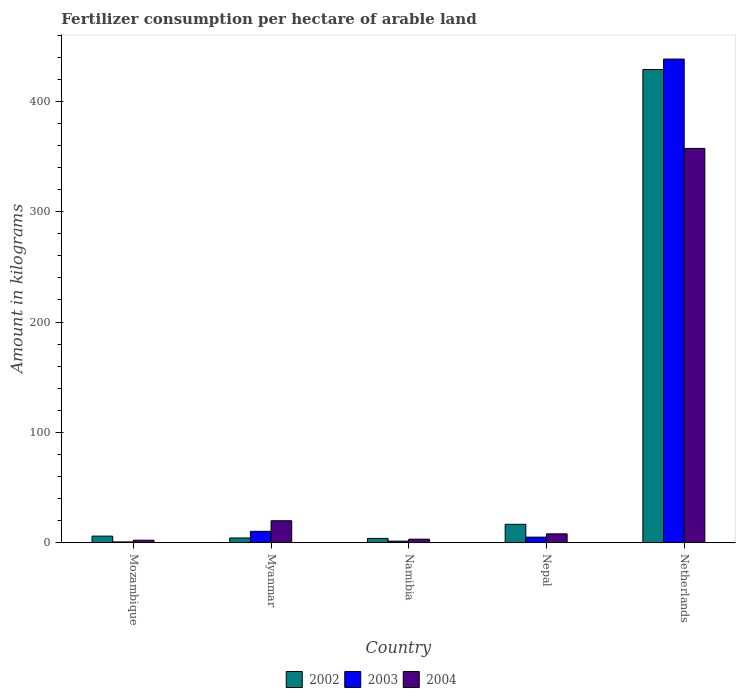How many different coloured bars are there?
Offer a terse response. 3. Are the number of bars per tick equal to the number of legend labels?
Offer a very short reply. Yes. Are the number of bars on each tick of the X-axis equal?
Your answer should be compact. Yes. How many bars are there on the 5th tick from the right?
Your answer should be very brief. 3. What is the label of the 4th group of bars from the left?
Ensure brevity in your answer.  Nepal. In how many cases, is the number of bars for a given country not equal to the number of legend labels?
Your answer should be very brief. 0. What is the amount of fertilizer consumption in 2002 in Namibia?
Keep it short and to the point. 3.9. Across all countries, what is the maximum amount of fertilizer consumption in 2002?
Provide a short and direct response. 428.82. Across all countries, what is the minimum amount of fertilizer consumption in 2003?
Offer a terse response. 0.74. In which country was the amount of fertilizer consumption in 2003 maximum?
Give a very brief answer. Netherlands. In which country was the amount of fertilizer consumption in 2003 minimum?
Provide a succinct answer. Mozambique. What is the total amount of fertilizer consumption in 2004 in the graph?
Your response must be concise. 390.72. What is the difference between the amount of fertilizer consumption in 2003 in Myanmar and that in Netherlands?
Your answer should be compact. -427.98. What is the difference between the amount of fertilizer consumption in 2004 in Mozambique and the amount of fertilizer consumption in 2002 in Namibia?
Offer a terse response. -1.64. What is the average amount of fertilizer consumption in 2004 per country?
Your response must be concise. 78.14. What is the difference between the amount of fertilizer consumption of/in 2003 and amount of fertilizer consumption of/in 2004 in Netherlands?
Offer a very short reply. 80.98. What is the ratio of the amount of fertilizer consumption in 2003 in Mozambique to that in Myanmar?
Give a very brief answer. 0.07. Is the amount of fertilizer consumption in 2004 in Myanmar less than that in Namibia?
Make the answer very short. No. What is the difference between the highest and the second highest amount of fertilizer consumption in 2002?
Offer a very short reply. -412.14. What is the difference between the highest and the lowest amount of fertilizer consumption in 2003?
Provide a short and direct response. 437.56. In how many countries, is the amount of fertilizer consumption in 2003 greater than the average amount of fertilizer consumption in 2003 taken over all countries?
Your response must be concise. 1. Is the sum of the amount of fertilizer consumption in 2004 in Mozambique and Myanmar greater than the maximum amount of fertilizer consumption in 2003 across all countries?
Your answer should be very brief. No. What does the 1st bar from the left in Namibia represents?
Provide a succinct answer. 2002. Is it the case that in every country, the sum of the amount of fertilizer consumption in 2002 and amount of fertilizer consumption in 2003 is greater than the amount of fertilizer consumption in 2004?
Make the answer very short. No. How many bars are there?
Offer a very short reply. 15. Are all the bars in the graph horizontal?
Your answer should be very brief. No. What is the difference between two consecutive major ticks on the Y-axis?
Provide a short and direct response. 100. Does the graph contain grids?
Ensure brevity in your answer.  No. Where does the legend appear in the graph?
Make the answer very short. Bottom center. What is the title of the graph?
Make the answer very short. Fertilizer consumption per hectare of arable land. Does "1986" appear as one of the legend labels in the graph?
Keep it short and to the point. No. What is the label or title of the Y-axis?
Your answer should be very brief. Amount in kilograms. What is the Amount in kilograms of 2002 in Mozambique?
Offer a terse response. 5.98. What is the Amount in kilograms in 2003 in Mozambique?
Provide a succinct answer. 0.74. What is the Amount in kilograms in 2004 in Mozambique?
Make the answer very short. 2.26. What is the Amount in kilograms in 2002 in Myanmar?
Your answer should be compact. 4.29. What is the Amount in kilograms of 2003 in Myanmar?
Ensure brevity in your answer.  10.31. What is the Amount in kilograms in 2004 in Myanmar?
Give a very brief answer. 19.91. What is the Amount in kilograms of 2002 in Namibia?
Your response must be concise. 3.9. What is the Amount in kilograms in 2003 in Namibia?
Your response must be concise. 1.41. What is the Amount in kilograms of 2004 in Namibia?
Give a very brief answer. 3.2. What is the Amount in kilograms of 2002 in Nepal?
Keep it short and to the point. 16.68. What is the Amount in kilograms in 2003 in Nepal?
Your answer should be compact. 5.06. What is the Amount in kilograms of 2004 in Nepal?
Offer a very short reply. 8.03. What is the Amount in kilograms of 2002 in Netherlands?
Make the answer very short. 428.82. What is the Amount in kilograms of 2003 in Netherlands?
Your response must be concise. 438.29. What is the Amount in kilograms in 2004 in Netherlands?
Provide a succinct answer. 357.31. Across all countries, what is the maximum Amount in kilograms of 2002?
Ensure brevity in your answer.  428.82. Across all countries, what is the maximum Amount in kilograms in 2003?
Ensure brevity in your answer.  438.29. Across all countries, what is the maximum Amount in kilograms in 2004?
Provide a succinct answer. 357.31. Across all countries, what is the minimum Amount in kilograms of 2002?
Ensure brevity in your answer.  3.9. Across all countries, what is the minimum Amount in kilograms in 2003?
Offer a very short reply. 0.74. Across all countries, what is the minimum Amount in kilograms in 2004?
Give a very brief answer. 2.26. What is the total Amount in kilograms in 2002 in the graph?
Offer a very short reply. 459.67. What is the total Amount in kilograms in 2003 in the graph?
Keep it short and to the point. 455.81. What is the total Amount in kilograms in 2004 in the graph?
Give a very brief answer. 390.72. What is the difference between the Amount in kilograms in 2002 in Mozambique and that in Myanmar?
Your answer should be very brief. 1.69. What is the difference between the Amount in kilograms of 2003 in Mozambique and that in Myanmar?
Ensure brevity in your answer.  -9.57. What is the difference between the Amount in kilograms in 2004 in Mozambique and that in Myanmar?
Your answer should be compact. -17.65. What is the difference between the Amount in kilograms of 2002 in Mozambique and that in Namibia?
Provide a succinct answer. 2.07. What is the difference between the Amount in kilograms of 2003 in Mozambique and that in Namibia?
Give a very brief answer. -0.67. What is the difference between the Amount in kilograms in 2004 in Mozambique and that in Namibia?
Give a very brief answer. -0.95. What is the difference between the Amount in kilograms in 2002 in Mozambique and that in Nepal?
Your answer should be compact. -10.7. What is the difference between the Amount in kilograms in 2003 in Mozambique and that in Nepal?
Keep it short and to the point. -4.32. What is the difference between the Amount in kilograms in 2004 in Mozambique and that in Nepal?
Your answer should be compact. -5.77. What is the difference between the Amount in kilograms in 2002 in Mozambique and that in Netherlands?
Ensure brevity in your answer.  -422.85. What is the difference between the Amount in kilograms in 2003 in Mozambique and that in Netherlands?
Provide a succinct answer. -437.56. What is the difference between the Amount in kilograms in 2004 in Mozambique and that in Netherlands?
Keep it short and to the point. -355.05. What is the difference between the Amount in kilograms in 2002 in Myanmar and that in Namibia?
Your response must be concise. 0.39. What is the difference between the Amount in kilograms of 2003 in Myanmar and that in Namibia?
Ensure brevity in your answer.  8.9. What is the difference between the Amount in kilograms in 2004 in Myanmar and that in Namibia?
Make the answer very short. 16.71. What is the difference between the Amount in kilograms of 2002 in Myanmar and that in Nepal?
Make the answer very short. -12.39. What is the difference between the Amount in kilograms in 2003 in Myanmar and that in Nepal?
Provide a short and direct response. 5.25. What is the difference between the Amount in kilograms of 2004 in Myanmar and that in Nepal?
Offer a very short reply. 11.89. What is the difference between the Amount in kilograms of 2002 in Myanmar and that in Netherlands?
Keep it short and to the point. -424.53. What is the difference between the Amount in kilograms of 2003 in Myanmar and that in Netherlands?
Provide a short and direct response. -427.98. What is the difference between the Amount in kilograms in 2004 in Myanmar and that in Netherlands?
Keep it short and to the point. -337.4. What is the difference between the Amount in kilograms of 2002 in Namibia and that in Nepal?
Your answer should be very brief. -12.78. What is the difference between the Amount in kilograms of 2003 in Namibia and that in Nepal?
Ensure brevity in your answer.  -3.65. What is the difference between the Amount in kilograms in 2004 in Namibia and that in Nepal?
Offer a terse response. -4.82. What is the difference between the Amount in kilograms in 2002 in Namibia and that in Netherlands?
Give a very brief answer. -424.92. What is the difference between the Amount in kilograms of 2003 in Namibia and that in Netherlands?
Your answer should be compact. -436.88. What is the difference between the Amount in kilograms in 2004 in Namibia and that in Netherlands?
Your answer should be compact. -354.11. What is the difference between the Amount in kilograms in 2002 in Nepal and that in Netherlands?
Your answer should be very brief. -412.14. What is the difference between the Amount in kilograms of 2003 in Nepal and that in Netherlands?
Your answer should be very brief. -433.23. What is the difference between the Amount in kilograms of 2004 in Nepal and that in Netherlands?
Keep it short and to the point. -349.29. What is the difference between the Amount in kilograms in 2002 in Mozambique and the Amount in kilograms in 2003 in Myanmar?
Offer a terse response. -4.33. What is the difference between the Amount in kilograms in 2002 in Mozambique and the Amount in kilograms in 2004 in Myanmar?
Ensure brevity in your answer.  -13.93. What is the difference between the Amount in kilograms of 2003 in Mozambique and the Amount in kilograms of 2004 in Myanmar?
Your response must be concise. -19.18. What is the difference between the Amount in kilograms of 2002 in Mozambique and the Amount in kilograms of 2003 in Namibia?
Make the answer very short. 4.57. What is the difference between the Amount in kilograms of 2002 in Mozambique and the Amount in kilograms of 2004 in Namibia?
Your answer should be compact. 2.77. What is the difference between the Amount in kilograms of 2003 in Mozambique and the Amount in kilograms of 2004 in Namibia?
Keep it short and to the point. -2.47. What is the difference between the Amount in kilograms of 2002 in Mozambique and the Amount in kilograms of 2003 in Nepal?
Give a very brief answer. 0.92. What is the difference between the Amount in kilograms in 2002 in Mozambique and the Amount in kilograms in 2004 in Nepal?
Your response must be concise. -2.05. What is the difference between the Amount in kilograms in 2003 in Mozambique and the Amount in kilograms in 2004 in Nepal?
Your answer should be very brief. -7.29. What is the difference between the Amount in kilograms of 2002 in Mozambique and the Amount in kilograms of 2003 in Netherlands?
Make the answer very short. -432.31. What is the difference between the Amount in kilograms of 2002 in Mozambique and the Amount in kilograms of 2004 in Netherlands?
Your answer should be very brief. -351.34. What is the difference between the Amount in kilograms in 2003 in Mozambique and the Amount in kilograms in 2004 in Netherlands?
Offer a terse response. -356.58. What is the difference between the Amount in kilograms in 2002 in Myanmar and the Amount in kilograms in 2003 in Namibia?
Ensure brevity in your answer.  2.88. What is the difference between the Amount in kilograms of 2002 in Myanmar and the Amount in kilograms of 2004 in Namibia?
Your answer should be very brief. 1.09. What is the difference between the Amount in kilograms of 2003 in Myanmar and the Amount in kilograms of 2004 in Namibia?
Your answer should be compact. 7.1. What is the difference between the Amount in kilograms of 2002 in Myanmar and the Amount in kilograms of 2003 in Nepal?
Your answer should be very brief. -0.77. What is the difference between the Amount in kilograms of 2002 in Myanmar and the Amount in kilograms of 2004 in Nepal?
Your answer should be very brief. -3.74. What is the difference between the Amount in kilograms in 2003 in Myanmar and the Amount in kilograms in 2004 in Nepal?
Provide a succinct answer. 2.28. What is the difference between the Amount in kilograms in 2002 in Myanmar and the Amount in kilograms in 2003 in Netherlands?
Give a very brief answer. -434. What is the difference between the Amount in kilograms in 2002 in Myanmar and the Amount in kilograms in 2004 in Netherlands?
Provide a succinct answer. -353.02. What is the difference between the Amount in kilograms in 2003 in Myanmar and the Amount in kilograms in 2004 in Netherlands?
Make the answer very short. -347. What is the difference between the Amount in kilograms of 2002 in Namibia and the Amount in kilograms of 2003 in Nepal?
Offer a terse response. -1.16. What is the difference between the Amount in kilograms of 2002 in Namibia and the Amount in kilograms of 2004 in Nepal?
Provide a succinct answer. -4.12. What is the difference between the Amount in kilograms of 2003 in Namibia and the Amount in kilograms of 2004 in Nepal?
Offer a terse response. -6.61. What is the difference between the Amount in kilograms in 2002 in Namibia and the Amount in kilograms in 2003 in Netherlands?
Ensure brevity in your answer.  -434.39. What is the difference between the Amount in kilograms of 2002 in Namibia and the Amount in kilograms of 2004 in Netherlands?
Your response must be concise. -353.41. What is the difference between the Amount in kilograms of 2003 in Namibia and the Amount in kilograms of 2004 in Netherlands?
Your answer should be compact. -355.9. What is the difference between the Amount in kilograms of 2002 in Nepal and the Amount in kilograms of 2003 in Netherlands?
Ensure brevity in your answer.  -421.61. What is the difference between the Amount in kilograms in 2002 in Nepal and the Amount in kilograms in 2004 in Netherlands?
Offer a very short reply. -340.63. What is the difference between the Amount in kilograms in 2003 in Nepal and the Amount in kilograms in 2004 in Netherlands?
Offer a very short reply. -352.25. What is the average Amount in kilograms of 2002 per country?
Offer a terse response. 91.94. What is the average Amount in kilograms of 2003 per country?
Your answer should be compact. 91.16. What is the average Amount in kilograms in 2004 per country?
Give a very brief answer. 78.14. What is the difference between the Amount in kilograms of 2002 and Amount in kilograms of 2003 in Mozambique?
Your answer should be very brief. 5.24. What is the difference between the Amount in kilograms in 2002 and Amount in kilograms in 2004 in Mozambique?
Provide a succinct answer. 3.72. What is the difference between the Amount in kilograms in 2003 and Amount in kilograms in 2004 in Mozambique?
Keep it short and to the point. -1.52. What is the difference between the Amount in kilograms of 2002 and Amount in kilograms of 2003 in Myanmar?
Make the answer very short. -6.02. What is the difference between the Amount in kilograms of 2002 and Amount in kilograms of 2004 in Myanmar?
Make the answer very short. -15.62. What is the difference between the Amount in kilograms in 2003 and Amount in kilograms in 2004 in Myanmar?
Keep it short and to the point. -9.6. What is the difference between the Amount in kilograms in 2002 and Amount in kilograms in 2003 in Namibia?
Offer a very short reply. 2.49. What is the difference between the Amount in kilograms in 2002 and Amount in kilograms in 2004 in Namibia?
Give a very brief answer. 0.7. What is the difference between the Amount in kilograms in 2003 and Amount in kilograms in 2004 in Namibia?
Give a very brief answer. -1.79. What is the difference between the Amount in kilograms in 2002 and Amount in kilograms in 2003 in Nepal?
Ensure brevity in your answer.  11.62. What is the difference between the Amount in kilograms in 2002 and Amount in kilograms in 2004 in Nepal?
Make the answer very short. 8.66. What is the difference between the Amount in kilograms in 2003 and Amount in kilograms in 2004 in Nepal?
Make the answer very short. -2.97. What is the difference between the Amount in kilograms of 2002 and Amount in kilograms of 2003 in Netherlands?
Provide a short and direct response. -9.47. What is the difference between the Amount in kilograms in 2002 and Amount in kilograms in 2004 in Netherlands?
Give a very brief answer. 71.51. What is the difference between the Amount in kilograms of 2003 and Amount in kilograms of 2004 in Netherlands?
Your answer should be very brief. 80.98. What is the ratio of the Amount in kilograms in 2002 in Mozambique to that in Myanmar?
Make the answer very short. 1.39. What is the ratio of the Amount in kilograms of 2003 in Mozambique to that in Myanmar?
Offer a terse response. 0.07. What is the ratio of the Amount in kilograms of 2004 in Mozambique to that in Myanmar?
Offer a very short reply. 0.11. What is the ratio of the Amount in kilograms of 2002 in Mozambique to that in Namibia?
Ensure brevity in your answer.  1.53. What is the ratio of the Amount in kilograms of 2003 in Mozambique to that in Namibia?
Make the answer very short. 0.52. What is the ratio of the Amount in kilograms in 2004 in Mozambique to that in Namibia?
Provide a succinct answer. 0.71. What is the ratio of the Amount in kilograms in 2002 in Mozambique to that in Nepal?
Offer a very short reply. 0.36. What is the ratio of the Amount in kilograms in 2003 in Mozambique to that in Nepal?
Provide a succinct answer. 0.15. What is the ratio of the Amount in kilograms in 2004 in Mozambique to that in Nepal?
Provide a short and direct response. 0.28. What is the ratio of the Amount in kilograms of 2002 in Mozambique to that in Netherlands?
Offer a very short reply. 0.01. What is the ratio of the Amount in kilograms in 2003 in Mozambique to that in Netherlands?
Provide a short and direct response. 0. What is the ratio of the Amount in kilograms of 2004 in Mozambique to that in Netherlands?
Give a very brief answer. 0.01. What is the ratio of the Amount in kilograms of 2002 in Myanmar to that in Namibia?
Provide a short and direct response. 1.1. What is the ratio of the Amount in kilograms in 2003 in Myanmar to that in Namibia?
Your response must be concise. 7.31. What is the ratio of the Amount in kilograms in 2004 in Myanmar to that in Namibia?
Your response must be concise. 6.21. What is the ratio of the Amount in kilograms in 2002 in Myanmar to that in Nepal?
Provide a short and direct response. 0.26. What is the ratio of the Amount in kilograms in 2003 in Myanmar to that in Nepal?
Provide a succinct answer. 2.04. What is the ratio of the Amount in kilograms in 2004 in Myanmar to that in Nepal?
Make the answer very short. 2.48. What is the ratio of the Amount in kilograms of 2003 in Myanmar to that in Netherlands?
Provide a succinct answer. 0.02. What is the ratio of the Amount in kilograms of 2004 in Myanmar to that in Netherlands?
Give a very brief answer. 0.06. What is the ratio of the Amount in kilograms in 2002 in Namibia to that in Nepal?
Keep it short and to the point. 0.23. What is the ratio of the Amount in kilograms in 2003 in Namibia to that in Nepal?
Ensure brevity in your answer.  0.28. What is the ratio of the Amount in kilograms in 2004 in Namibia to that in Nepal?
Make the answer very short. 0.4. What is the ratio of the Amount in kilograms in 2002 in Namibia to that in Netherlands?
Provide a short and direct response. 0.01. What is the ratio of the Amount in kilograms of 2003 in Namibia to that in Netherlands?
Offer a very short reply. 0. What is the ratio of the Amount in kilograms in 2004 in Namibia to that in Netherlands?
Your response must be concise. 0.01. What is the ratio of the Amount in kilograms in 2002 in Nepal to that in Netherlands?
Ensure brevity in your answer.  0.04. What is the ratio of the Amount in kilograms of 2003 in Nepal to that in Netherlands?
Your answer should be compact. 0.01. What is the ratio of the Amount in kilograms in 2004 in Nepal to that in Netherlands?
Ensure brevity in your answer.  0.02. What is the difference between the highest and the second highest Amount in kilograms of 2002?
Offer a very short reply. 412.14. What is the difference between the highest and the second highest Amount in kilograms in 2003?
Provide a succinct answer. 427.98. What is the difference between the highest and the second highest Amount in kilograms of 2004?
Give a very brief answer. 337.4. What is the difference between the highest and the lowest Amount in kilograms in 2002?
Offer a very short reply. 424.92. What is the difference between the highest and the lowest Amount in kilograms in 2003?
Make the answer very short. 437.56. What is the difference between the highest and the lowest Amount in kilograms in 2004?
Offer a very short reply. 355.05. 